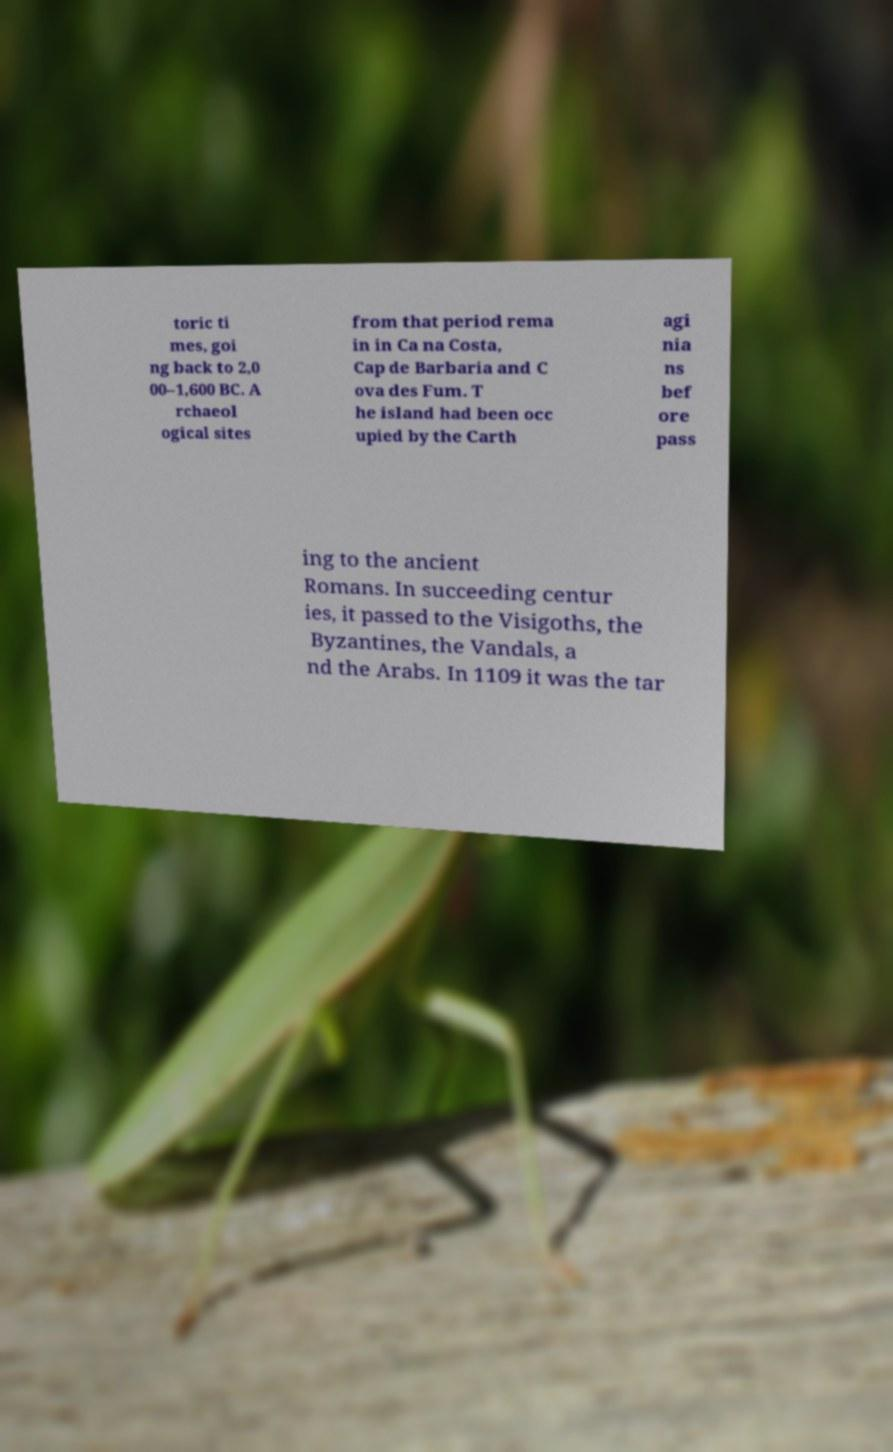What messages or text are displayed in this image? I need them in a readable, typed format. toric ti mes, goi ng back to 2,0 00–1,600 BC. A rchaeol ogical sites from that period rema in in Ca na Costa, Cap de Barbaria and C ova des Fum. T he island had been occ upied by the Carth agi nia ns bef ore pass ing to the ancient Romans. In succeeding centur ies, it passed to the Visigoths, the Byzantines, the Vandals, a nd the Arabs. In 1109 it was the tar 